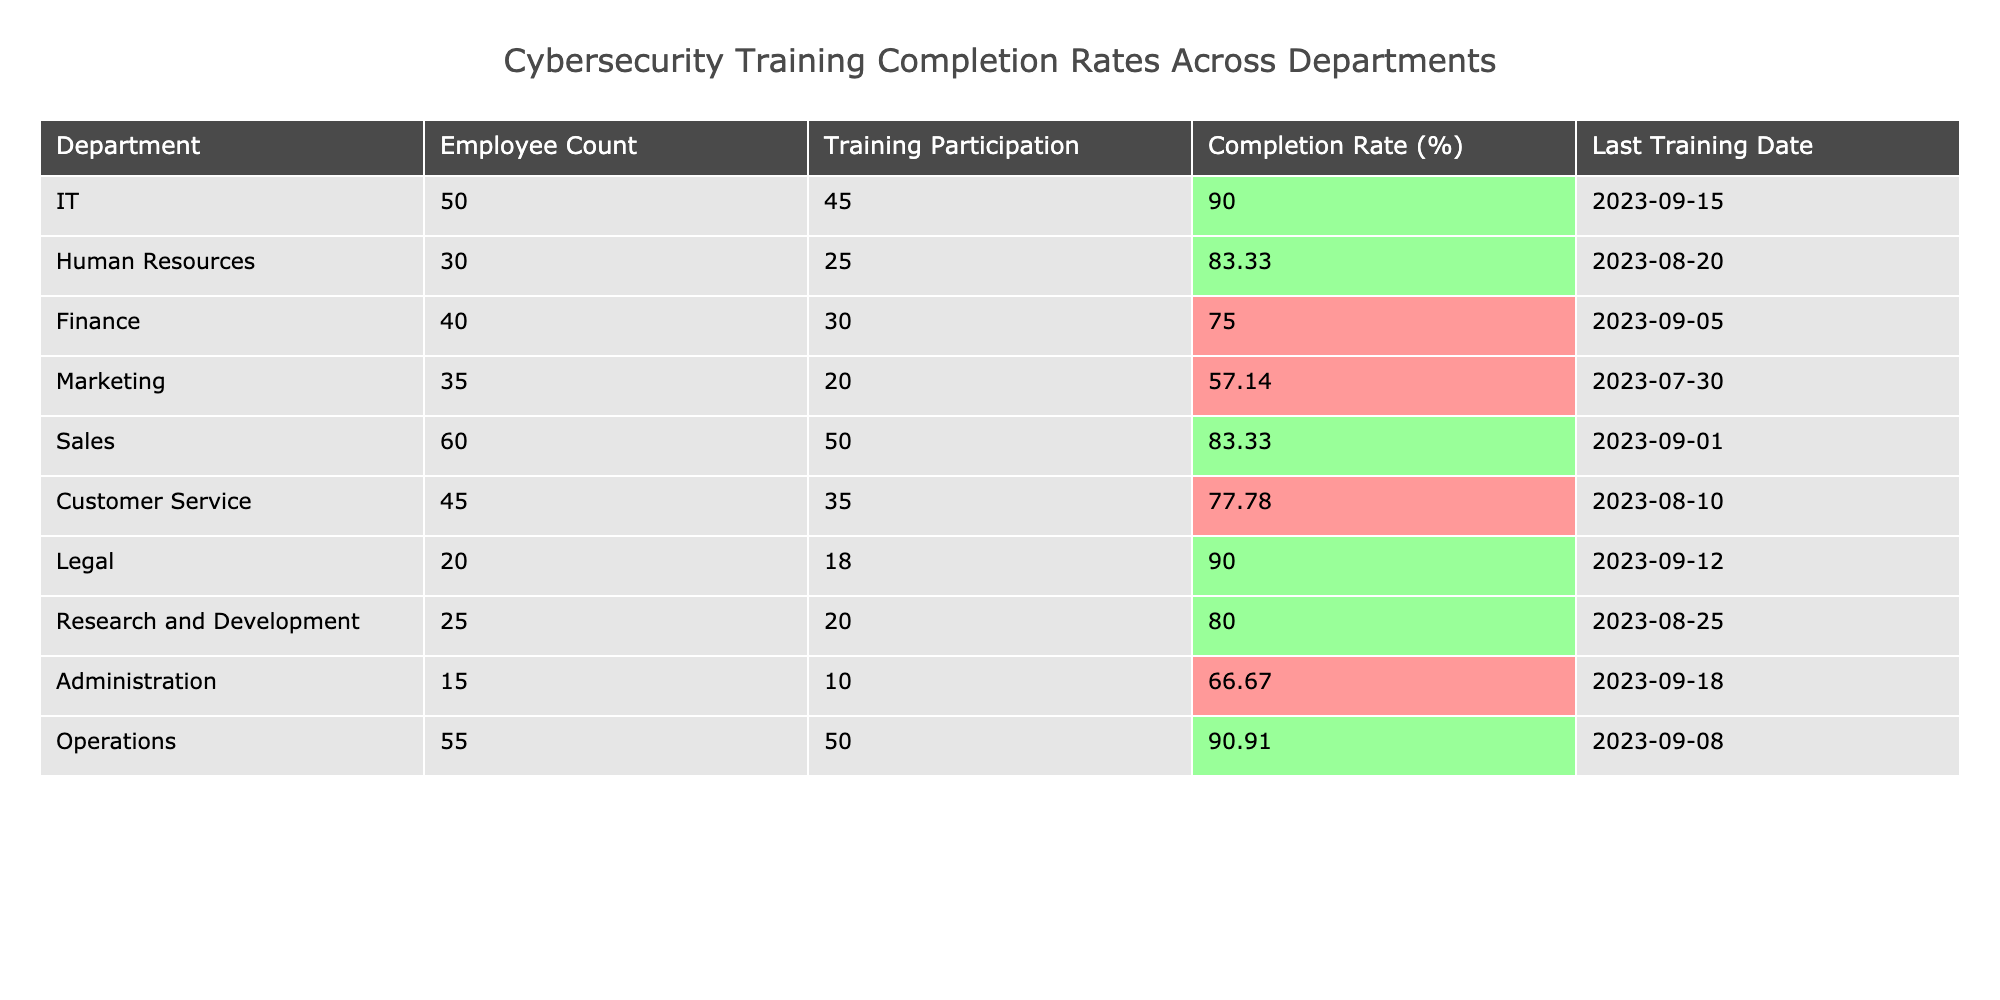What is the completion rate for the IT department? The table indicates that the completion rate for the IT department is 90%.
Answer: 90% Which department has the lowest completion rate? In the table, Marketing department has the lowest completion rate of 57.14%.
Answer: Marketing What is the average completion rate across all departments? To find the average, sum the completion rates: (90 + 83.33 + 75 + 57.14 + 83.33 + 77.78 + 90 + 80 + 66.67 + 90.91) and divide by the number of departments (10). The sum is 835.16 and average is 835.16 / 10 = 83.52%.
Answer: 83.52% How many employees in the Finance department participated in the training? The table shows that 30 employees from the Finance department participated in the training.
Answer: 30 Did the Customer Service department achieve a completion rate above 75%? Looking at the table, the Customer Service department has a completion rate of 77.78%, which is above 75%.
Answer: Yes Which two departments have the same training completion rate? By examining the table, both IT and Operations departments have a completion rate of 90%.
Answer: IT and Operations What is the difference between the highest and lowest completion rates? According to the table, the highest completion rate is 90% (IT and Operations) and the lowest is 57.14% (Marketing). The difference is 90 - 57.14 = 32.86%.
Answer: 32.86% How many departments have a completion rate of 80% or higher? Upon reviewing the table, the departments with completion rates of 80% or higher are IT, Legal, Operations, and R&D, totaling 4 departments.
Answer: 4 What percentage of employees in the Administration department completed their training? The table states that the completion rate for the Administration department is 66.67%.
Answer: 66.67% Which department improved its completion rate the most since its last training date? To determine improvement, we need to compare completion rates from previous periods. If we assume the comparisons are made with a hypothetical lower rate, Sales and Legal might show significant improvement due to showing higher completion rates of 83.33% and 90%, respectively. For a definitive answer, historical data would be needed.
Answer: Data needed for definitive answer 